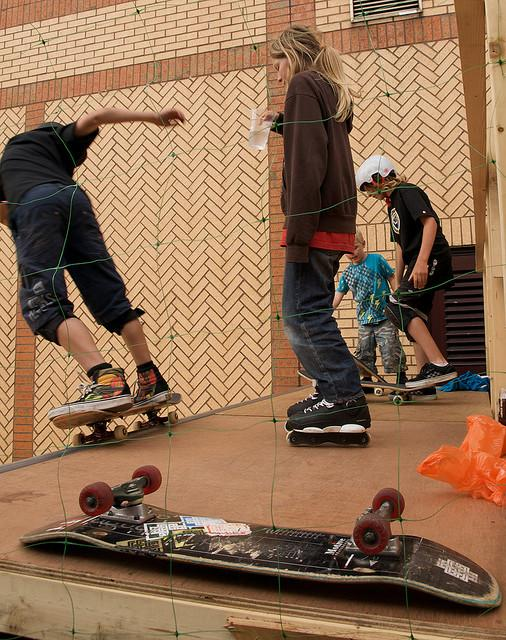This girl has similar hair color to what actress? Please explain your reasoning. michelle pfeiffer. The girl has blonde hair.  jessica chastain has red hair, brooke shields has brown hair, isabelle adjani has black hair and the remaining actress is a blonde. 